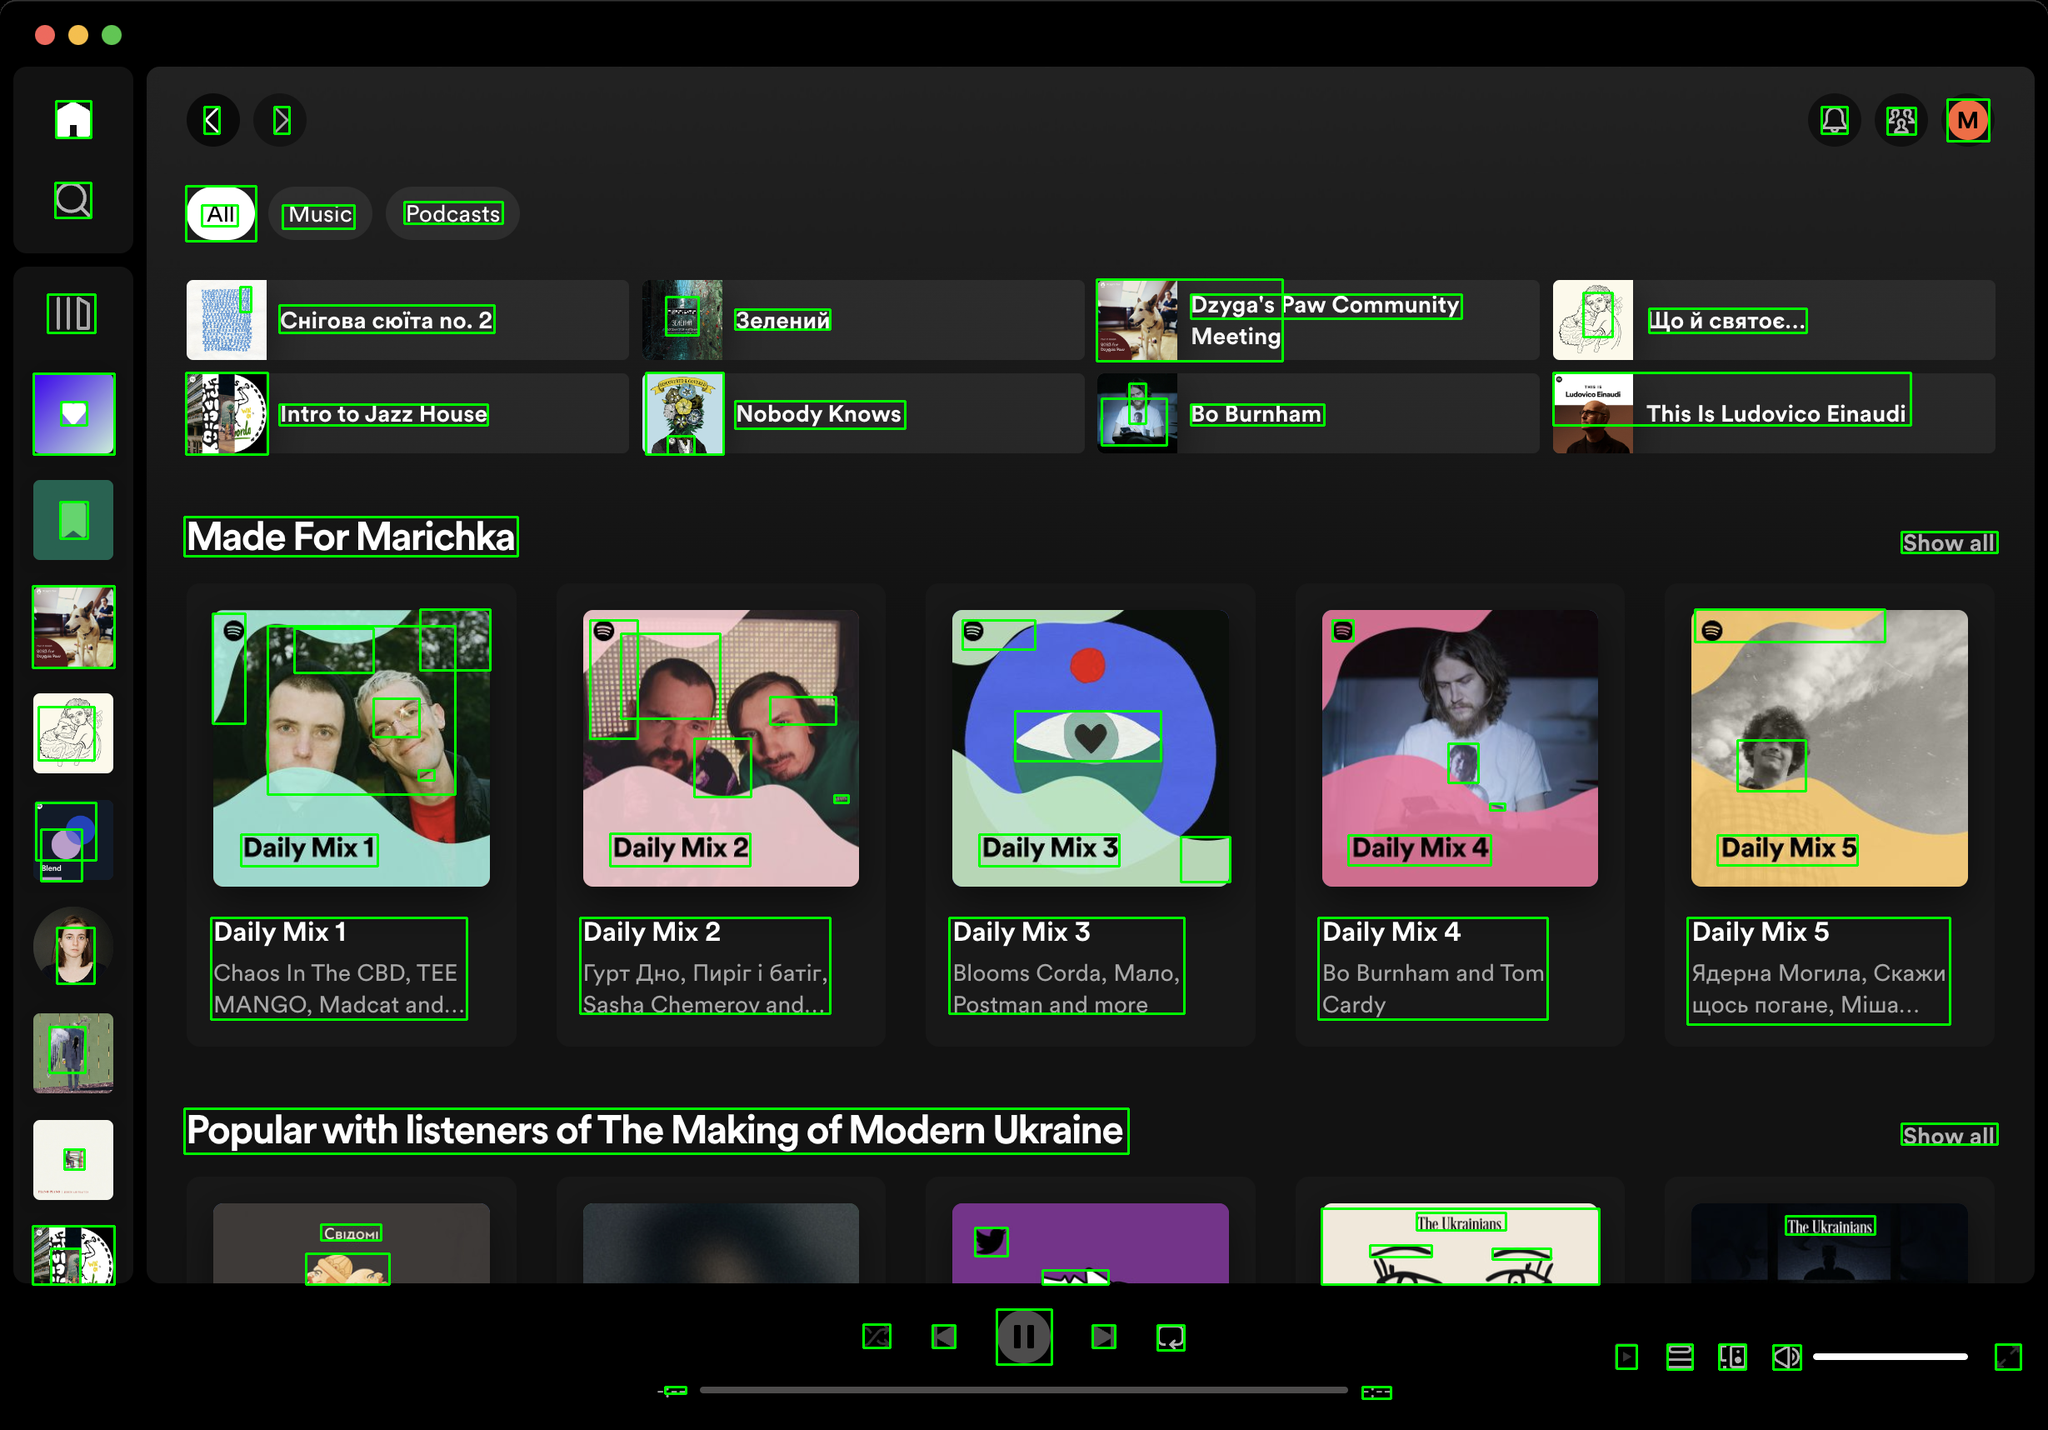You are an AI designed for image processing and segmentation analysis, particularly skilled in merging segmented regions of an image to improve accuracy and readability.

**Task Description:**
Your task is to address a user's concern with a UI screenshot of the Spotify application on MacOS. The screenshot contains multiple green boxes, each representing a UI element, with a unique white number outlined in black ranging from 1 to 95. Due to segmentation issues, some boxes that belong to the same image are divided unnaturally.

**Objective:**
Merge these segmented areas that correspond to a single UI element to create a coherent representation. The final output should be in JSON format, where each key-value pair represents the merged areas.

**Example JSON Output:**
If boxes with numbers 1, 2, and 3 should belong to the same UI element, the JSON output should be:

```json
{
    "Image A Life In Lyrics": [1, 2, 3]
}
```

**Instructions:**

- **Identify Segmented Regions:** Analyze the screenshot to identify which green boxes belong to the same UI element.
- **Merge Regions:** Group the numbers of these boxes together to represent a single UI element.
- **Output Format:** Produce the output in JSON format, with each key representing a UI element and each value being a list of the numbers of the merged boxes. Don't include in the result UI elements that consist of one box.

**Primary Objective:**
Ensure the accuracy of the merged regions based on the user's supplied image information, maintaining the integrity and structure of the UI elements in the Spotify application on MacOS. Based on the provided screenshot, I have identified the segmented regions that belong to the same UI elements and merged them accordingly. Here is the JSON output representing the merged areas:

```json
{
    "Chirova siota no. 2": [1, 2],
    "Zeleniy": [3, 4],
    "Dzyga's Paw Community Meeting": [5, 6],
    "Intro to Jazz House": [7, 8],
    "Nobody Knows": [9, 10],
    "Bo Burnham": [11, 12],
    "Daily Mix 1": [13, 14, 15, 16],
    "Daily Mix 2": [17, 18, 19, 20],
    "Daily Mix 3": [21, 22, 23, 24],
    "Daily Mix 4": [25, 26, 27, 28],
    "Daily Mix 5": [29, 30, 31, 32],
    "This Is Ludovico Einaudi": [33, 34],
    "Popular with listeners of The Making of Modern Ukraine": [35, 36, 37, 38, 39, 40, 41, 42, 43, 44, 45, 46, 47, 48, 49, 50, 51, 52, 53, 54, 55, 56, 57, 58, 59, 60, 61, 62, 63, 64, 65, 66, 67, 68, 69, 70, 71, 72, 73, 74, 75, 76, 77, 78, 79, 80, 81, 82, 83, 84, 85, 86, 87, 88, 89, 90, 91, 92, 93, 94, 95]
}
```

This JSON output groups the segmented boxes that belong to the same UI elements, ensuring a coherent representation of the UI elements in the Spotify application on MacOS. 